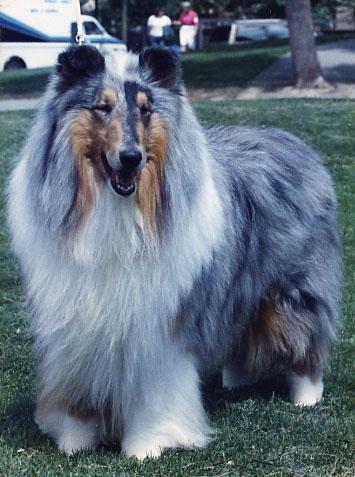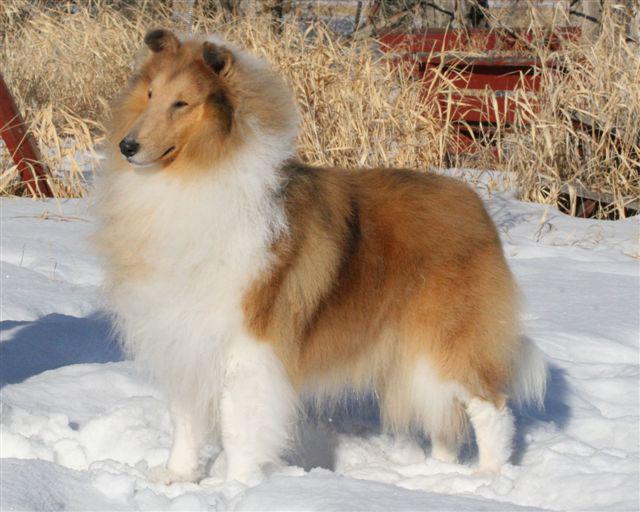The first image is the image on the left, the second image is the image on the right. For the images displayed, is the sentence "There are five collies in total." factually correct? Answer yes or no. No. The first image is the image on the left, the second image is the image on the right. Analyze the images presented: Is the assertion "One image contains three collie dogs, and the other contains two." valid? Answer yes or no. No. 